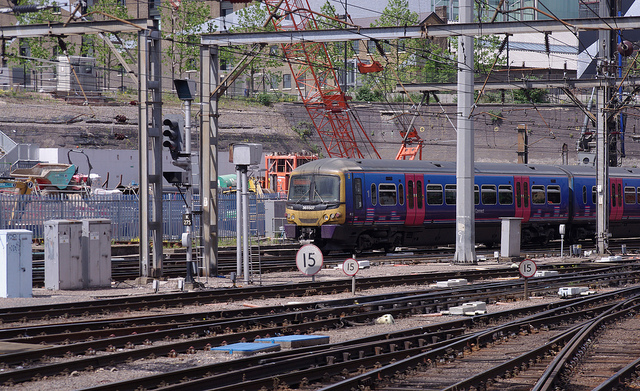<image>Where is the train going? It is unknown where the train is going. It could be going to the station, to the city, or to London. Where is the train going? It is not clear where the train is going. It can be going to London, to the station, or nowhere. 